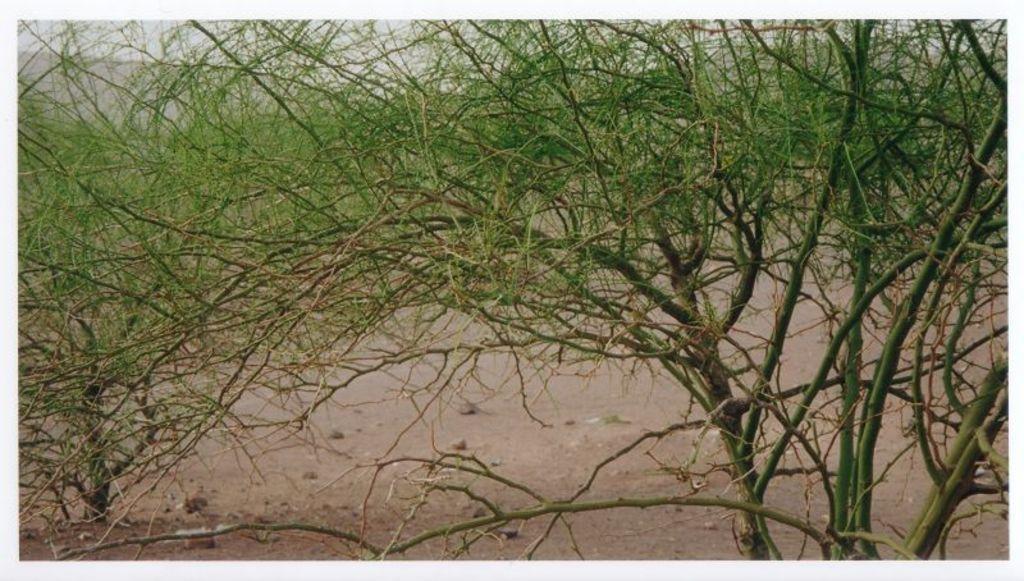Can you describe this image briefly? This image is taken outdoors. At the bottom of the image there is a ground. In this image there are many trees. 